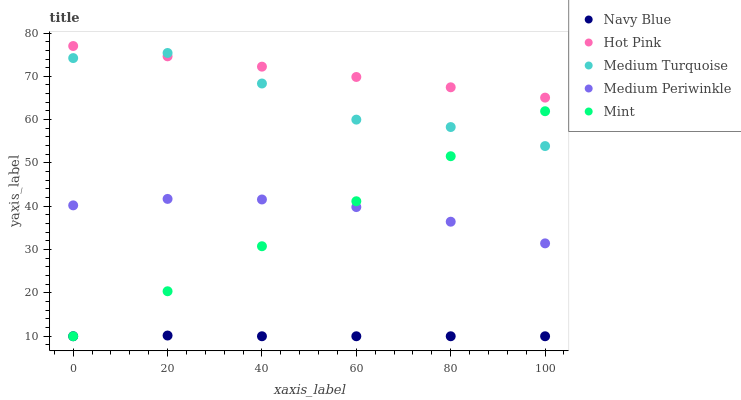Does Navy Blue have the minimum area under the curve?
Answer yes or no. Yes. Does Hot Pink have the maximum area under the curve?
Answer yes or no. Yes. Does Medium Periwinkle have the minimum area under the curve?
Answer yes or no. No. Does Medium Periwinkle have the maximum area under the curve?
Answer yes or no. No. Is Mint the smoothest?
Answer yes or no. Yes. Is Medium Turquoise the roughest?
Answer yes or no. Yes. Is Hot Pink the smoothest?
Answer yes or no. No. Is Hot Pink the roughest?
Answer yes or no. No. Does Navy Blue have the lowest value?
Answer yes or no. Yes. Does Medium Periwinkle have the lowest value?
Answer yes or no. No. Does Hot Pink have the highest value?
Answer yes or no. Yes. Does Medium Periwinkle have the highest value?
Answer yes or no. No. Is Medium Periwinkle less than Medium Turquoise?
Answer yes or no. Yes. Is Hot Pink greater than Medium Periwinkle?
Answer yes or no. Yes. Does Mint intersect Medium Turquoise?
Answer yes or no. Yes. Is Mint less than Medium Turquoise?
Answer yes or no. No. Is Mint greater than Medium Turquoise?
Answer yes or no. No. Does Medium Periwinkle intersect Medium Turquoise?
Answer yes or no. No. 